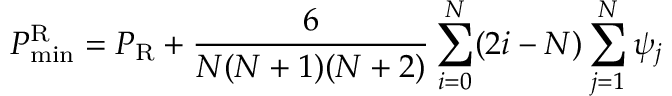<formula> <loc_0><loc_0><loc_500><loc_500>P _ { \min } ^ { \mathrm R } = P _ { \mathrm R } + { \frac { 6 } { N ( N + 1 ) ( N + 2 ) } } \sum _ { i = 0 } ^ { N } ( 2 i - N ) \sum _ { j = 1 } ^ { N } \psi _ { j }</formula> 